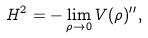<formula> <loc_0><loc_0><loc_500><loc_500>H ^ { 2 } = - \lim _ { \rho \rightarrow 0 } V ( \rho ) ^ { \prime \prime } ,</formula> 